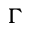<formula> <loc_0><loc_0><loc_500><loc_500>\Gamma</formula> 